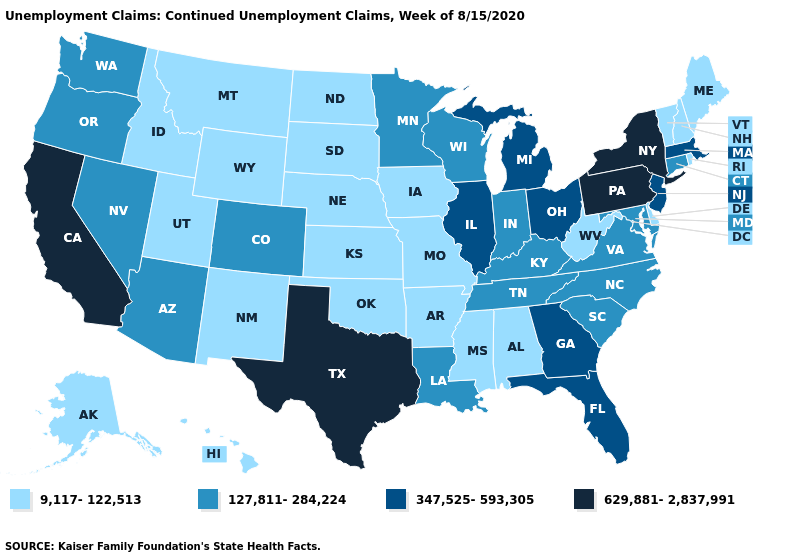How many symbols are there in the legend?
Give a very brief answer. 4. Among the states that border Tennessee , does Alabama have the lowest value?
Quick response, please. Yes. Does Hawaii have the same value as New York?
Keep it brief. No. Name the states that have a value in the range 127,811-284,224?
Write a very short answer. Arizona, Colorado, Connecticut, Indiana, Kentucky, Louisiana, Maryland, Minnesota, Nevada, North Carolina, Oregon, South Carolina, Tennessee, Virginia, Washington, Wisconsin. Name the states that have a value in the range 127,811-284,224?
Write a very short answer. Arizona, Colorado, Connecticut, Indiana, Kentucky, Louisiana, Maryland, Minnesota, Nevada, North Carolina, Oregon, South Carolina, Tennessee, Virginia, Washington, Wisconsin. What is the value of Louisiana?
Be succinct. 127,811-284,224. Does the map have missing data?
Short answer required. No. What is the value of Alaska?
Concise answer only. 9,117-122,513. Does the map have missing data?
Answer briefly. No. What is the highest value in states that border Colorado?
Short answer required. 127,811-284,224. Name the states that have a value in the range 127,811-284,224?
Quick response, please. Arizona, Colorado, Connecticut, Indiana, Kentucky, Louisiana, Maryland, Minnesota, Nevada, North Carolina, Oregon, South Carolina, Tennessee, Virginia, Washington, Wisconsin. What is the highest value in the USA?
Short answer required. 629,881-2,837,991. Does Alabama have the lowest value in the South?
Concise answer only. Yes. Among the states that border Rhode Island , which have the lowest value?
Be succinct. Connecticut. 